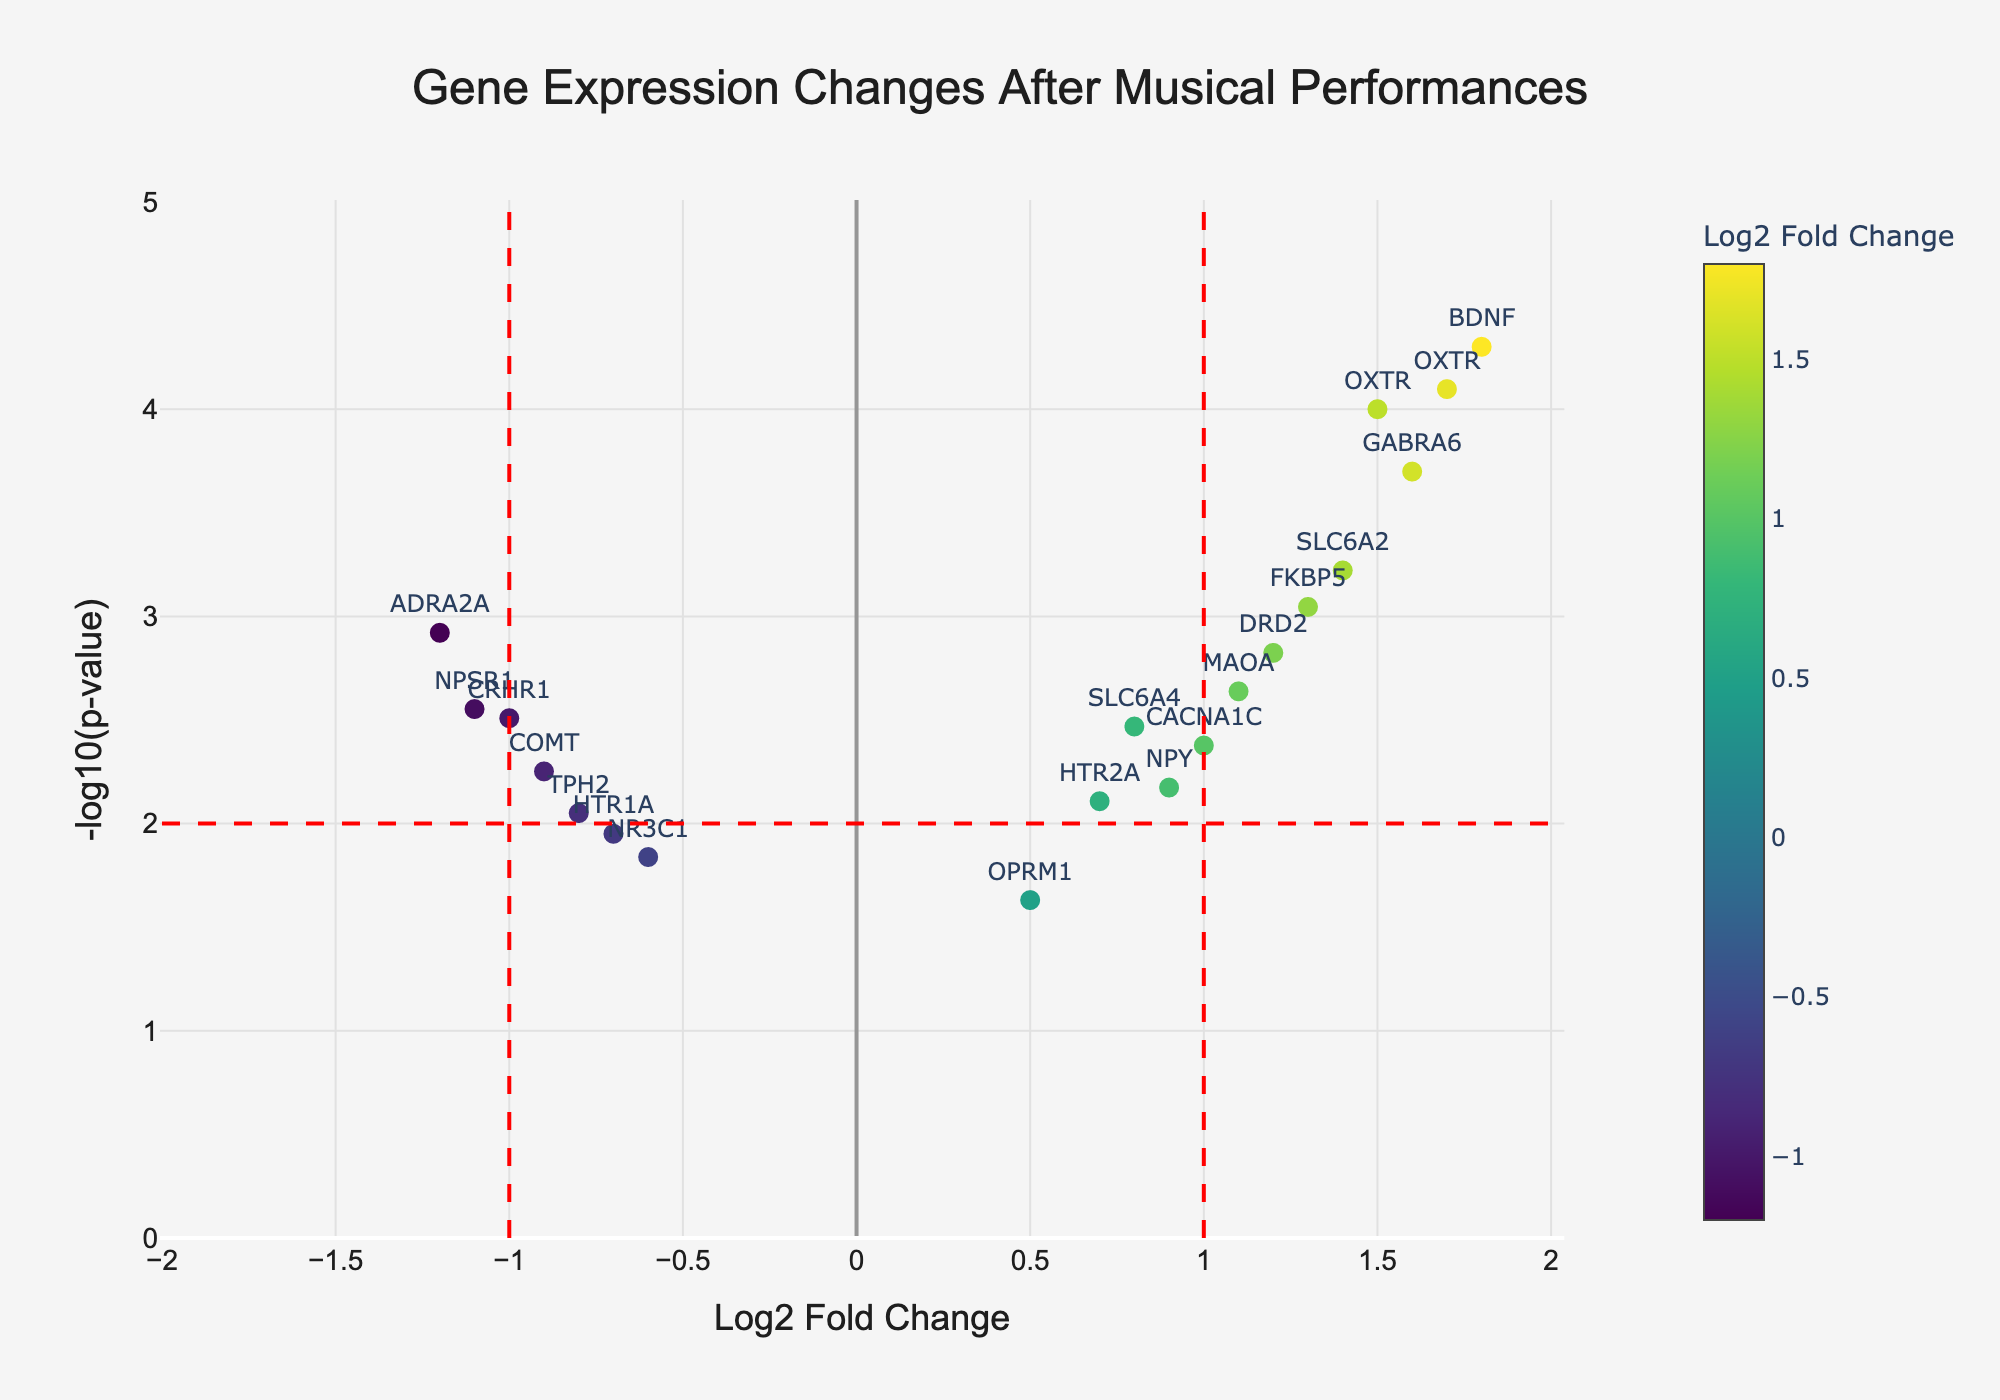What is the title of the figure? The title is located at the top of the figure and is typically highlighted in a larger font to catch the viewer's attention.
Answer: Gene Expression Changes After Musical Performances What are the labels for the x and y axes? The x-axis label is "Log2 Fold Change," and the y-axis label is "-log10(p-value)," which can be found along the bottom and side of the plot, respectively.
Answer: Log2 Fold Change and -log10(p-value) How many genes are plotted in the figure? By counting each data point (which represents a gene) in the plot, we can determine the number of genes.
Answer: 18 Which gene has the highest Log2 Fold Change? By looking at the data points along the x-axis, the gene OXTR (+1.7) has the highest Log2 Fold Change.
Answer: OXTR Which gene has the smallest p-value? The -log10(p-value) conversion means the smallest p-value corresponds to the highest y-axis value. BDNF, with a -log10(p-value) of 4.301, has the smallest p-value.
Answer: BDNF Are there any genes with both significant fold changes and small p-values? Significant fold changes would be values noticeably greater or smaller than 0, and small p-values would appear higher on the y-axis. Examples include BDNF, OXTR, and GABRA6.
Answer: Yes, BDNF, OXTR, and GABRA6 What do the colored points represent? The colors indicate the Log2 Fold Change values, with the color scale shown on the right of the plot; higher values are represented by warmer colors.
Answer: Log2 Fold Change values How many genes showed a decrease in expression (negative Log2 Fold Change)? Data points left of the zero value on the x-axis represent genes with a decrease in expression. There are seven such points.
Answer: 7 genes Of the genes with a positive Log2 Fold Change, which has the highest statistical significance? For positive Log2 Fold Change values (right side of the plot), the highest point corresponds to the most statistically significant. OXTR, with the highest point in this region, has the highest significance.
Answer: OXTR How many genes have a Log2 Fold Change between -1 and 1? Counting data points within the Log2 Fold Change range of -1 to 1 (excluding the thresholds at -1 and 1) gives us the number of such genes. There are eight points in this range.
Answer: 8 genes 